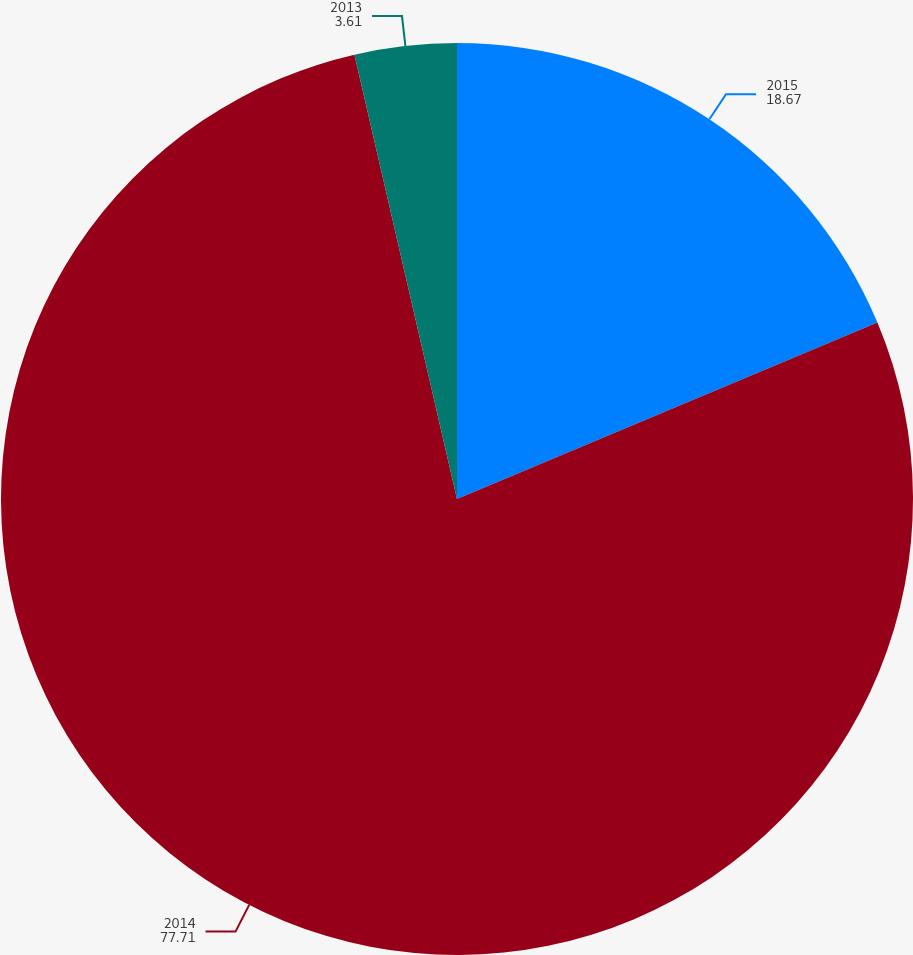<chart> <loc_0><loc_0><loc_500><loc_500><pie_chart><fcel>2015<fcel>2014<fcel>2013<nl><fcel>18.67%<fcel>77.71%<fcel>3.61%<nl></chart> 